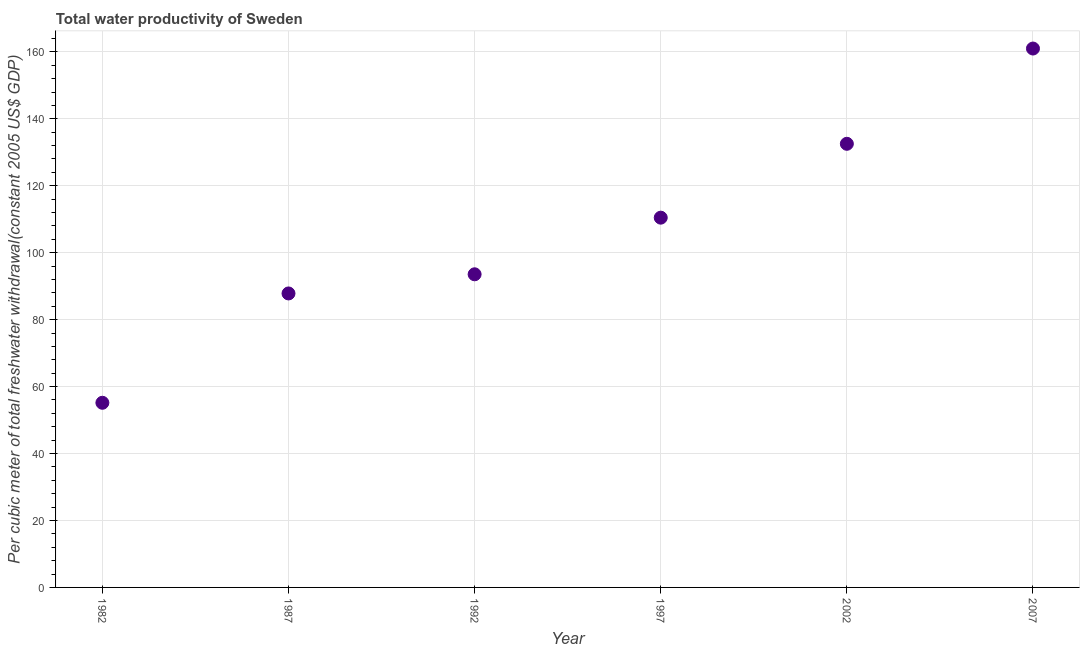What is the total water productivity in 1987?
Your response must be concise. 87.82. Across all years, what is the maximum total water productivity?
Your answer should be very brief. 160.99. Across all years, what is the minimum total water productivity?
Provide a succinct answer. 55.16. In which year was the total water productivity maximum?
Give a very brief answer. 2007. What is the sum of the total water productivity?
Provide a succinct answer. 640.52. What is the difference between the total water productivity in 2002 and 2007?
Offer a terse response. -28.46. What is the average total water productivity per year?
Your answer should be very brief. 106.75. What is the median total water productivity?
Ensure brevity in your answer.  102.01. In how many years, is the total water productivity greater than 148 US$?
Give a very brief answer. 1. What is the ratio of the total water productivity in 1992 to that in 2002?
Ensure brevity in your answer.  0.71. Is the difference between the total water productivity in 1987 and 2007 greater than the difference between any two years?
Offer a very short reply. No. What is the difference between the highest and the second highest total water productivity?
Keep it short and to the point. 28.46. Is the sum of the total water productivity in 2002 and 2007 greater than the maximum total water productivity across all years?
Give a very brief answer. Yes. What is the difference between the highest and the lowest total water productivity?
Give a very brief answer. 105.83. In how many years, is the total water productivity greater than the average total water productivity taken over all years?
Make the answer very short. 3. Does the total water productivity monotonically increase over the years?
Your response must be concise. Yes. Does the graph contain any zero values?
Your answer should be very brief. No. What is the title of the graph?
Keep it short and to the point. Total water productivity of Sweden. What is the label or title of the X-axis?
Offer a terse response. Year. What is the label or title of the Y-axis?
Offer a very short reply. Per cubic meter of total freshwater withdrawal(constant 2005 US$ GDP). What is the Per cubic meter of total freshwater withdrawal(constant 2005 US$ GDP) in 1982?
Your answer should be very brief. 55.16. What is the Per cubic meter of total freshwater withdrawal(constant 2005 US$ GDP) in 1987?
Your answer should be very brief. 87.82. What is the Per cubic meter of total freshwater withdrawal(constant 2005 US$ GDP) in 1992?
Give a very brief answer. 93.55. What is the Per cubic meter of total freshwater withdrawal(constant 2005 US$ GDP) in 1997?
Your answer should be compact. 110.46. What is the Per cubic meter of total freshwater withdrawal(constant 2005 US$ GDP) in 2002?
Your answer should be very brief. 132.53. What is the Per cubic meter of total freshwater withdrawal(constant 2005 US$ GDP) in 2007?
Your answer should be very brief. 160.99. What is the difference between the Per cubic meter of total freshwater withdrawal(constant 2005 US$ GDP) in 1982 and 1987?
Provide a short and direct response. -32.66. What is the difference between the Per cubic meter of total freshwater withdrawal(constant 2005 US$ GDP) in 1982 and 1992?
Provide a succinct answer. -38.38. What is the difference between the Per cubic meter of total freshwater withdrawal(constant 2005 US$ GDP) in 1982 and 1997?
Give a very brief answer. -55.3. What is the difference between the Per cubic meter of total freshwater withdrawal(constant 2005 US$ GDP) in 1982 and 2002?
Offer a terse response. -77.37. What is the difference between the Per cubic meter of total freshwater withdrawal(constant 2005 US$ GDP) in 1982 and 2007?
Provide a succinct answer. -105.83. What is the difference between the Per cubic meter of total freshwater withdrawal(constant 2005 US$ GDP) in 1987 and 1992?
Your answer should be very brief. -5.72. What is the difference between the Per cubic meter of total freshwater withdrawal(constant 2005 US$ GDP) in 1987 and 1997?
Offer a terse response. -22.64. What is the difference between the Per cubic meter of total freshwater withdrawal(constant 2005 US$ GDP) in 1987 and 2002?
Ensure brevity in your answer.  -44.71. What is the difference between the Per cubic meter of total freshwater withdrawal(constant 2005 US$ GDP) in 1987 and 2007?
Ensure brevity in your answer.  -73.17. What is the difference between the Per cubic meter of total freshwater withdrawal(constant 2005 US$ GDP) in 1992 and 1997?
Give a very brief answer. -16.92. What is the difference between the Per cubic meter of total freshwater withdrawal(constant 2005 US$ GDP) in 1992 and 2002?
Keep it short and to the point. -38.99. What is the difference between the Per cubic meter of total freshwater withdrawal(constant 2005 US$ GDP) in 1992 and 2007?
Provide a short and direct response. -67.44. What is the difference between the Per cubic meter of total freshwater withdrawal(constant 2005 US$ GDP) in 1997 and 2002?
Provide a short and direct response. -22.07. What is the difference between the Per cubic meter of total freshwater withdrawal(constant 2005 US$ GDP) in 1997 and 2007?
Your answer should be very brief. -50.53. What is the difference between the Per cubic meter of total freshwater withdrawal(constant 2005 US$ GDP) in 2002 and 2007?
Make the answer very short. -28.46. What is the ratio of the Per cubic meter of total freshwater withdrawal(constant 2005 US$ GDP) in 1982 to that in 1987?
Keep it short and to the point. 0.63. What is the ratio of the Per cubic meter of total freshwater withdrawal(constant 2005 US$ GDP) in 1982 to that in 1992?
Your answer should be very brief. 0.59. What is the ratio of the Per cubic meter of total freshwater withdrawal(constant 2005 US$ GDP) in 1982 to that in 1997?
Offer a terse response. 0.5. What is the ratio of the Per cubic meter of total freshwater withdrawal(constant 2005 US$ GDP) in 1982 to that in 2002?
Offer a very short reply. 0.42. What is the ratio of the Per cubic meter of total freshwater withdrawal(constant 2005 US$ GDP) in 1982 to that in 2007?
Provide a succinct answer. 0.34. What is the ratio of the Per cubic meter of total freshwater withdrawal(constant 2005 US$ GDP) in 1987 to that in 1992?
Provide a succinct answer. 0.94. What is the ratio of the Per cubic meter of total freshwater withdrawal(constant 2005 US$ GDP) in 1987 to that in 1997?
Keep it short and to the point. 0.8. What is the ratio of the Per cubic meter of total freshwater withdrawal(constant 2005 US$ GDP) in 1987 to that in 2002?
Your response must be concise. 0.66. What is the ratio of the Per cubic meter of total freshwater withdrawal(constant 2005 US$ GDP) in 1987 to that in 2007?
Give a very brief answer. 0.55. What is the ratio of the Per cubic meter of total freshwater withdrawal(constant 2005 US$ GDP) in 1992 to that in 1997?
Keep it short and to the point. 0.85. What is the ratio of the Per cubic meter of total freshwater withdrawal(constant 2005 US$ GDP) in 1992 to that in 2002?
Your answer should be very brief. 0.71. What is the ratio of the Per cubic meter of total freshwater withdrawal(constant 2005 US$ GDP) in 1992 to that in 2007?
Give a very brief answer. 0.58. What is the ratio of the Per cubic meter of total freshwater withdrawal(constant 2005 US$ GDP) in 1997 to that in 2002?
Your answer should be very brief. 0.83. What is the ratio of the Per cubic meter of total freshwater withdrawal(constant 2005 US$ GDP) in 1997 to that in 2007?
Give a very brief answer. 0.69. What is the ratio of the Per cubic meter of total freshwater withdrawal(constant 2005 US$ GDP) in 2002 to that in 2007?
Keep it short and to the point. 0.82. 